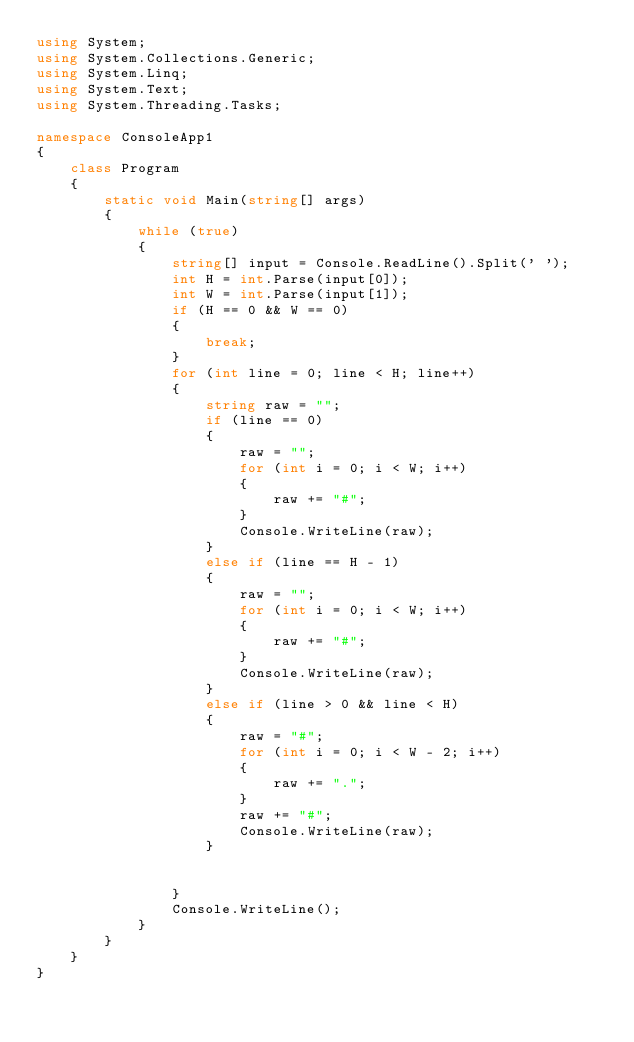Convert code to text. <code><loc_0><loc_0><loc_500><loc_500><_C#_>using System;
using System.Collections.Generic;
using System.Linq;
using System.Text;
using System.Threading.Tasks;

namespace ConsoleApp1
{
    class Program
    {
        static void Main(string[] args)
        {
            while (true)
            {
                string[] input = Console.ReadLine().Split(' ');
                int H = int.Parse(input[0]);
                int W = int.Parse(input[1]);
                if (H == 0 && W == 0)
                {
                    break;
                }
                for (int line = 0; line < H; line++)
                {
                    string raw = "";
                    if (line == 0)
                    {
                        raw = "";
                        for (int i = 0; i < W; i++)
                        {
                            raw += "#";
                        }
                        Console.WriteLine(raw);
                    }
                    else if (line == H - 1)
                    {
                        raw = "";
                        for (int i = 0; i < W; i++)
                        {
                            raw += "#";
                        }
                        Console.WriteLine(raw);
                    }
                    else if (line > 0 && line < H)
                    {
                        raw = "#";
                        for (int i = 0; i < W - 2; i++)
                        {
                            raw += ".";
                        }
                        raw += "#";
                        Console.WriteLine(raw);
                    }


                }
                Console.WriteLine();
            }
        }
    }
}
</code> 